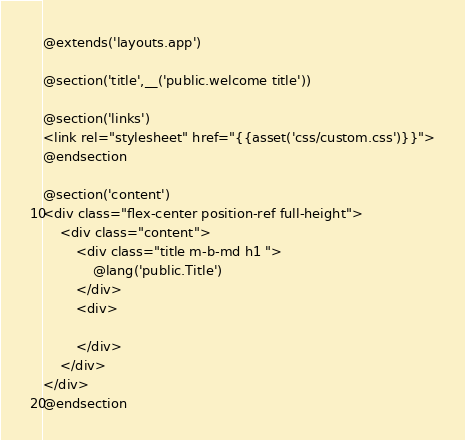Convert code to text. <code><loc_0><loc_0><loc_500><loc_500><_PHP_>@extends('layouts.app')

@section('title',__('public.welcome title'))

@section('links')
<link rel="stylesheet" href="{{asset('css/custom.css')}}">
@endsection

@section('content')
<div class="flex-center position-ref full-height">
    <div class="content">
        <div class="title m-b-md h1 ">
            @lang('public.Title')
        </div>
        <div>

        </div>
    </div>
</div>
@endsection</code> 